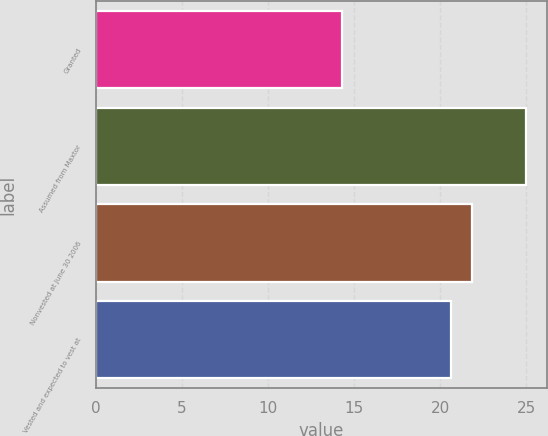<chart> <loc_0><loc_0><loc_500><loc_500><bar_chart><fcel>Granted<fcel>Assumed from Maxtor<fcel>Nonvested at June 30 2006<fcel>Vested and expected to vest at<nl><fcel>14.28<fcel>24.95<fcel>21.84<fcel>20.65<nl></chart> 